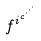<formula> <loc_0><loc_0><loc_500><loc_500>f ^ { i ^ { c ^ { \cdot ^ { \cdot ^ { \cdot } } } } }</formula> 